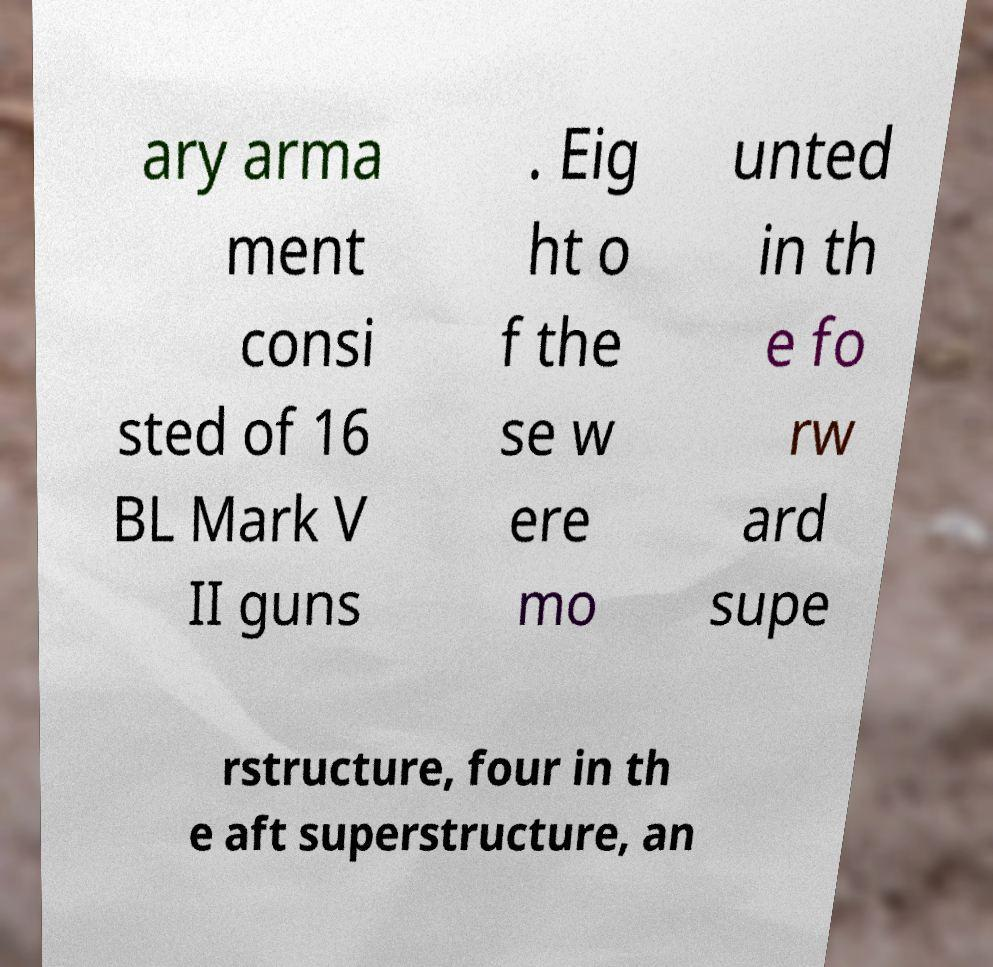Please read and relay the text visible in this image. What does it say? ary arma ment consi sted of 16 BL Mark V II guns . Eig ht o f the se w ere mo unted in th e fo rw ard supe rstructure, four in th e aft superstructure, an 